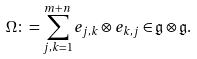<formula> <loc_0><loc_0><loc_500><loc_500>\Omega \colon = \sum _ { j , k = 1 } ^ { m + n } e _ { j , k } \otimes e _ { k , j } \in \mathfrak { g } \otimes \mathfrak { g } .</formula> 